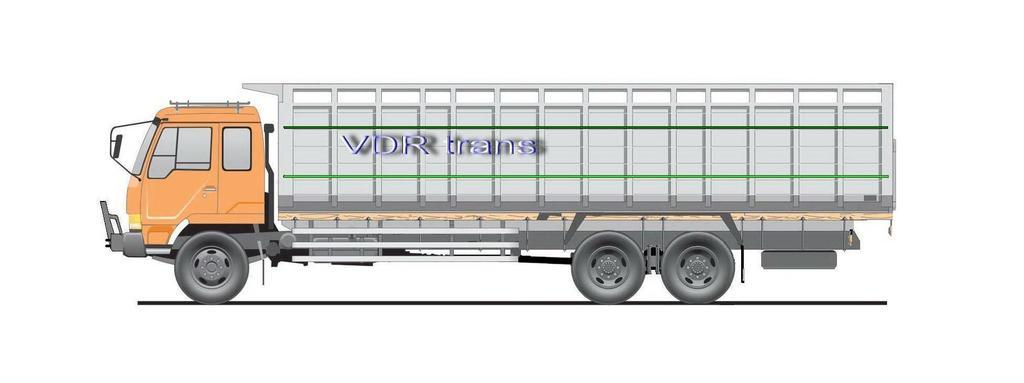What type of image is being described? The image is animated. What can be seen on the road in the image? There is a vehicle on the road in the image. What additional detail can be observed on the vehicle? There is text written on the vehicle. What type of pie is being served on the vehicle in the image? There is no pie present in the image; it is a vehicle on the road with text written on it. How many crates are stacked next to the vehicle in the image? There are no crates present in the image; it only features a vehicle on the road with text written on it. 